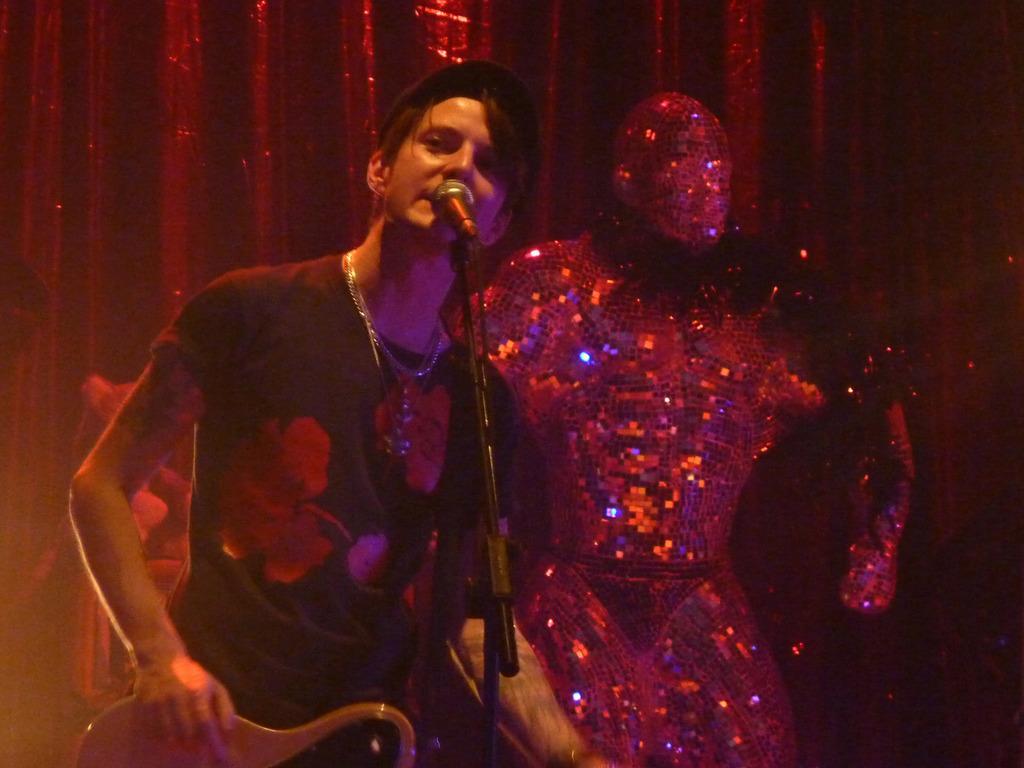Please provide a concise description of this image. In the middle of the image we can see a microphone. Behind the microphone a person is standing and holding a guitar. Behind him there is a statue and cloth. 